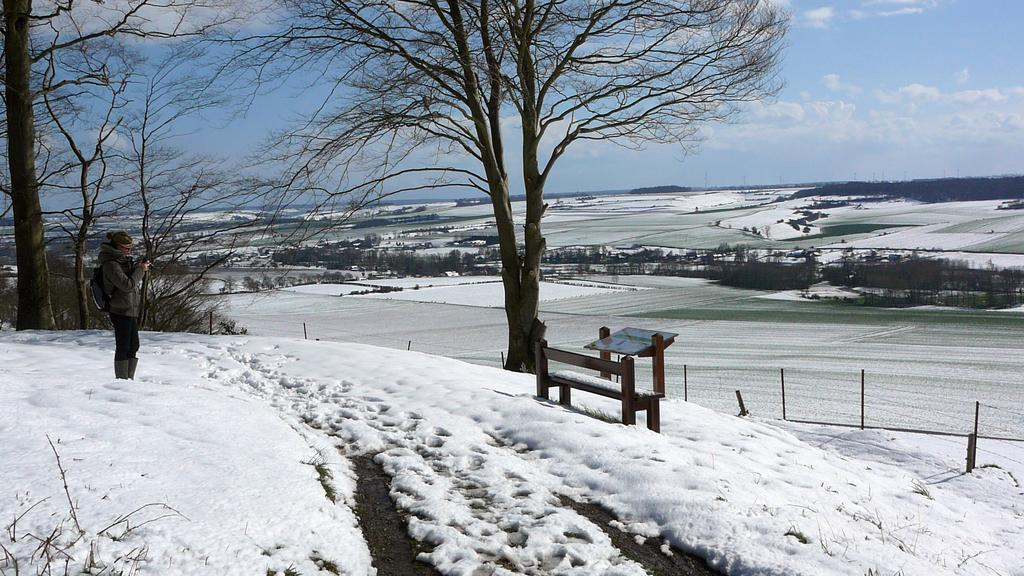What is the person in the image standing on? The person is standing on the snow. What objects are on the right side of the person? There are poles, a bench, and a board on the right side of the person. What type of vegetation is visible behind the person? There are trees visible behind the person. What is visible in the sky behind the person? The sky is visible behind the person. What type of popcorn is being served on the bench in the image? There is no popcorn present in the image; it features a person standing on snow with objects on the right side and trees and sky visible behind. 